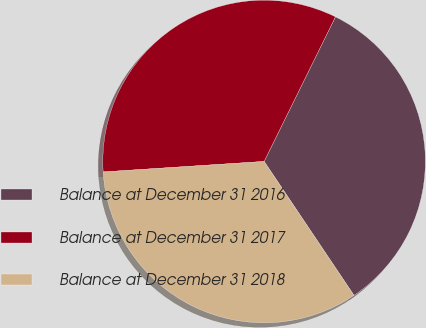Convert chart. <chart><loc_0><loc_0><loc_500><loc_500><pie_chart><fcel>Balance at December 31 2016<fcel>Balance at December 31 2017<fcel>Balance at December 31 2018<nl><fcel>33.3%<fcel>33.33%<fcel>33.37%<nl></chart> 